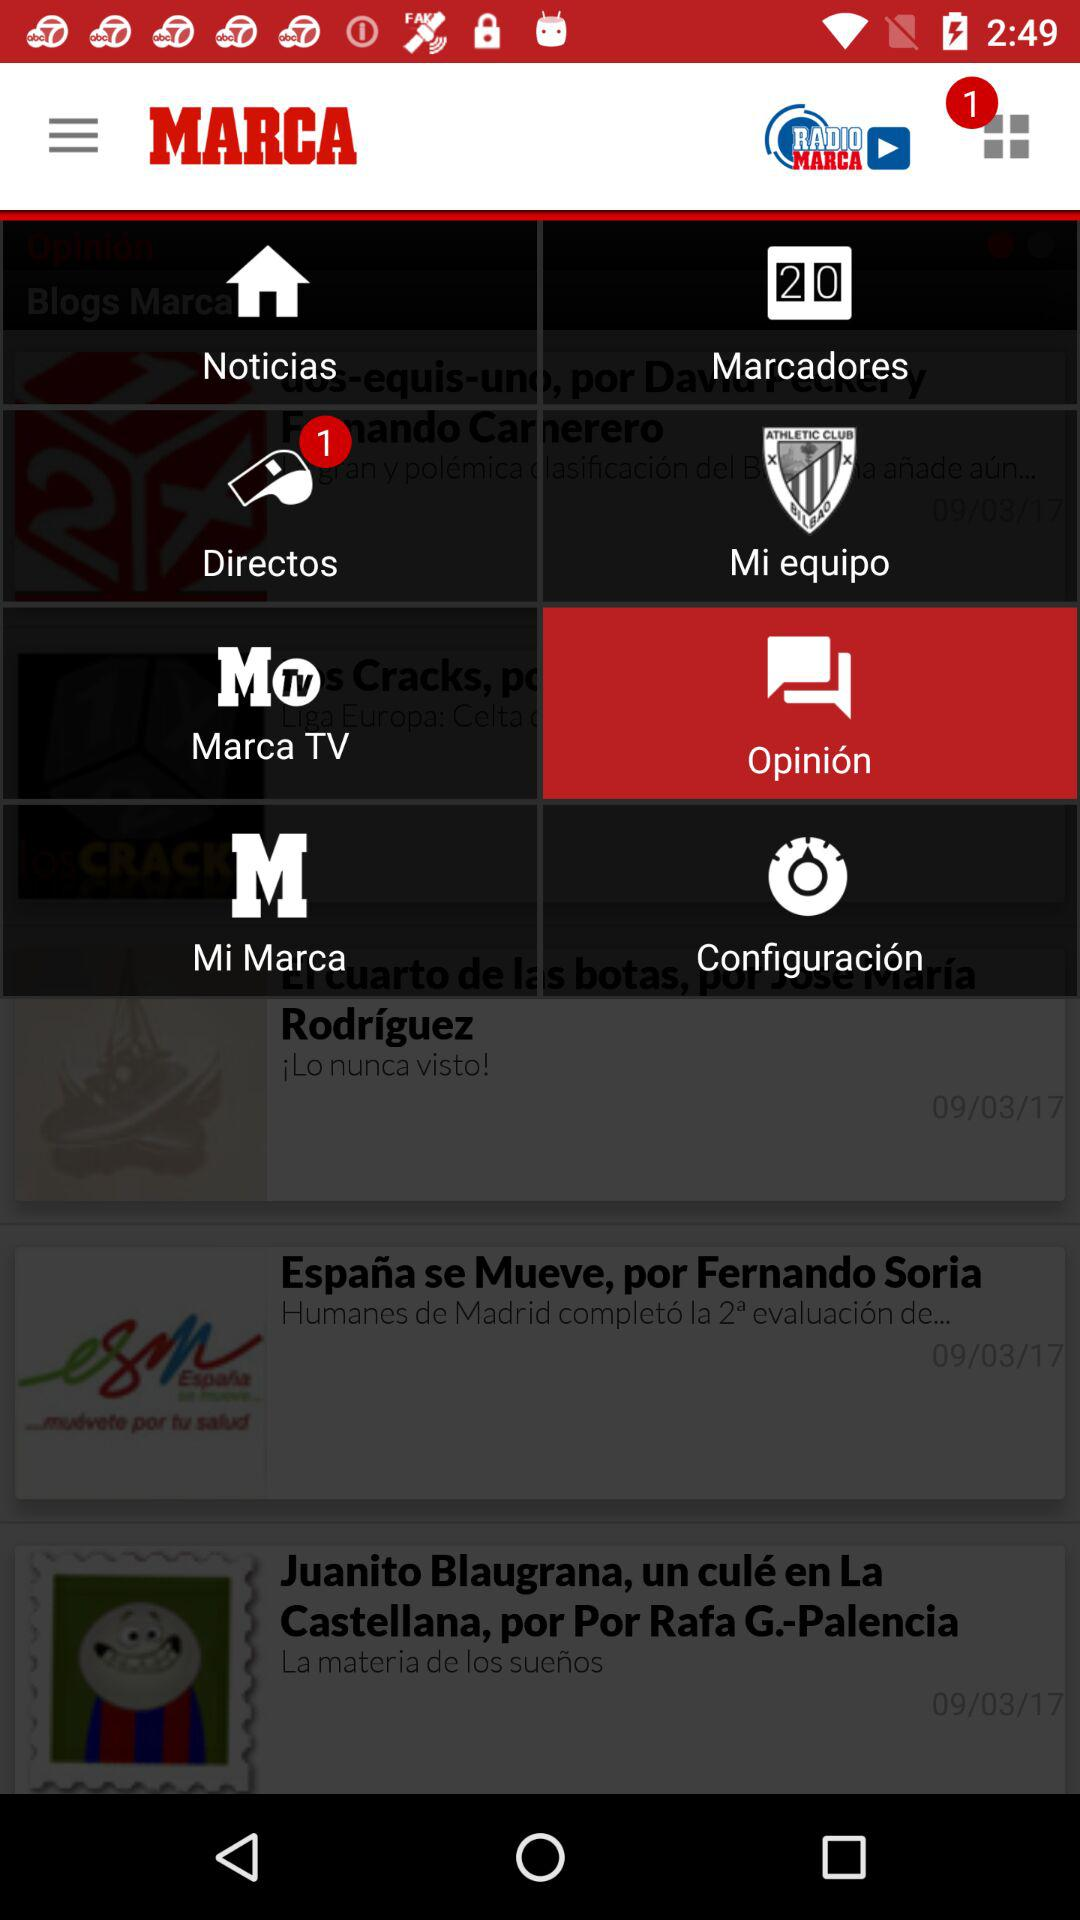Which option has been selected? The selected option is "Opinion". 